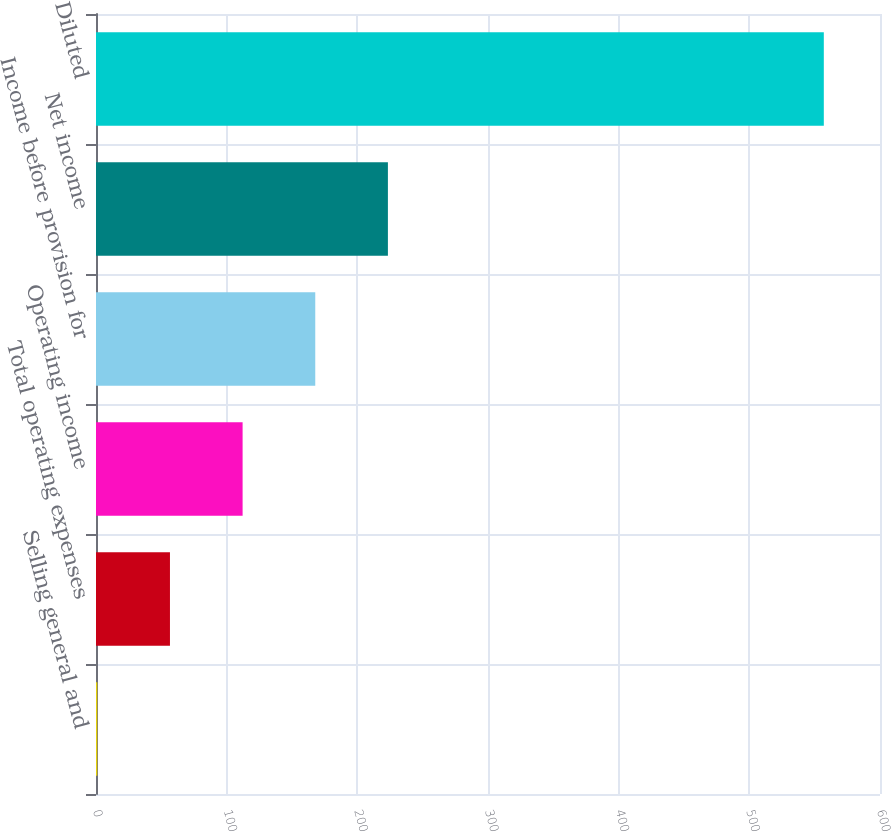<chart> <loc_0><loc_0><loc_500><loc_500><bar_chart><fcel>Selling general and<fcel>Total operating expenses<fcel>Operating income<fcel>Income before provision for<fcel>Net income<fcel>Diluted<nl><fcel>1<fcel>56.6<fcel>112.2<fcel>167.8<fcel>223.4<fcel>557<nl></chart> 